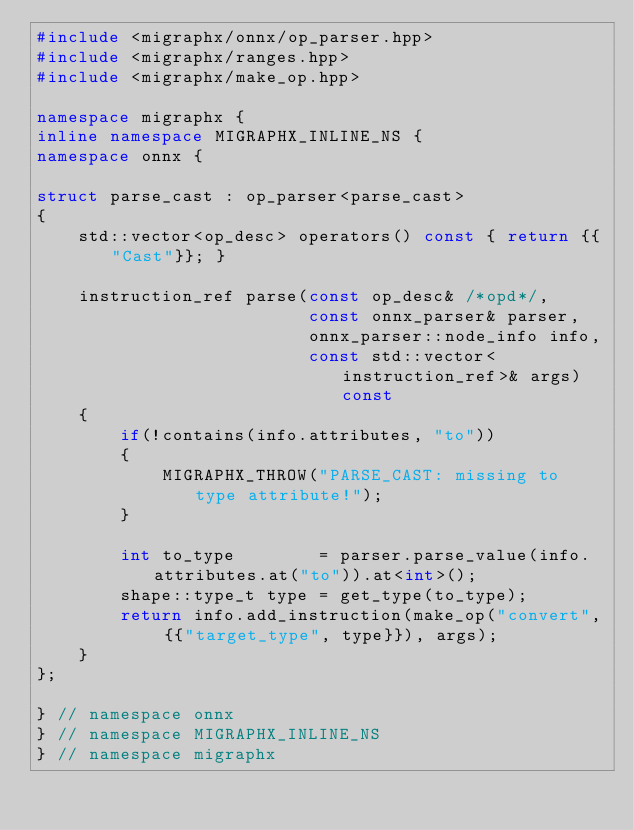Convert code to text. <code><loc_0><loc_0><loc_500><loc_500><_C++_>#include <migraphx/onnx/op_parser.hpp>
#include <migraphx/ranges.hpp>
#include <migraphx/make_op.hpp>

namespace migraphx {
inline namespace MIGRAPHX_INLINE_NS {
namespace onnx {

struct parse_cast : op_parser<parse_cast>
{
    std::vector<op_desc> operators() const { return {{"Cast"}}; }

    instruction_ref parse(const op_desc& /*opd*/,
                          const onnx_parser& parser,
                          onnx_parser::node_info info,
                          const std::vector<instruction_ref>& args) const
    {
        if(!contains(info.attributes, "to"))
        {
            MIGRAPHX_THROW("PARSE_CAST: missing to type attribute!");
        }

        int to_type        = parser.parse_value(info.attributes.at("to")).at<int>();
        shape::type_t type = get_type(to_type);
        return info.add_instruction(make_op("convert", {{"target_type", type}}), args);
    }
};

} // namespace onnx
} // namespace MIGRAPHX_INLINE_NS
} // namespace migraphx
</code> 